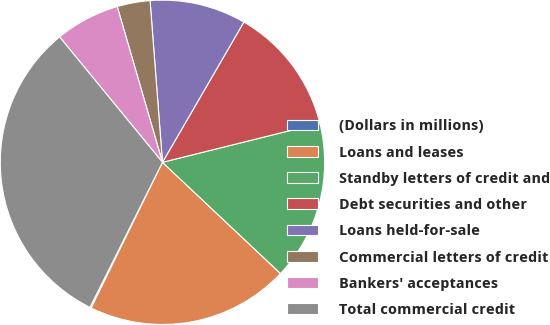<chart> <loc_0><loc_0><loc_500><loc_500><pie_chart><fcel>(Dollars in millions)<fcel>Loans and leases<fcel>Standby letters of credit and<fcel>Debt securities and other<fcel>Loans held-for-sale<fcel>Commercial letters of credit<fcel>Bankers' acceptances<fcel>Total commercial credit<nl><fcel>0.13%<fcel>20.22%<fcel>15.91%<fcel>12.75%<fcel>9.59%<fcel>3.28%<fcel>6.44%<fcel>31.69%<nl></chart> 